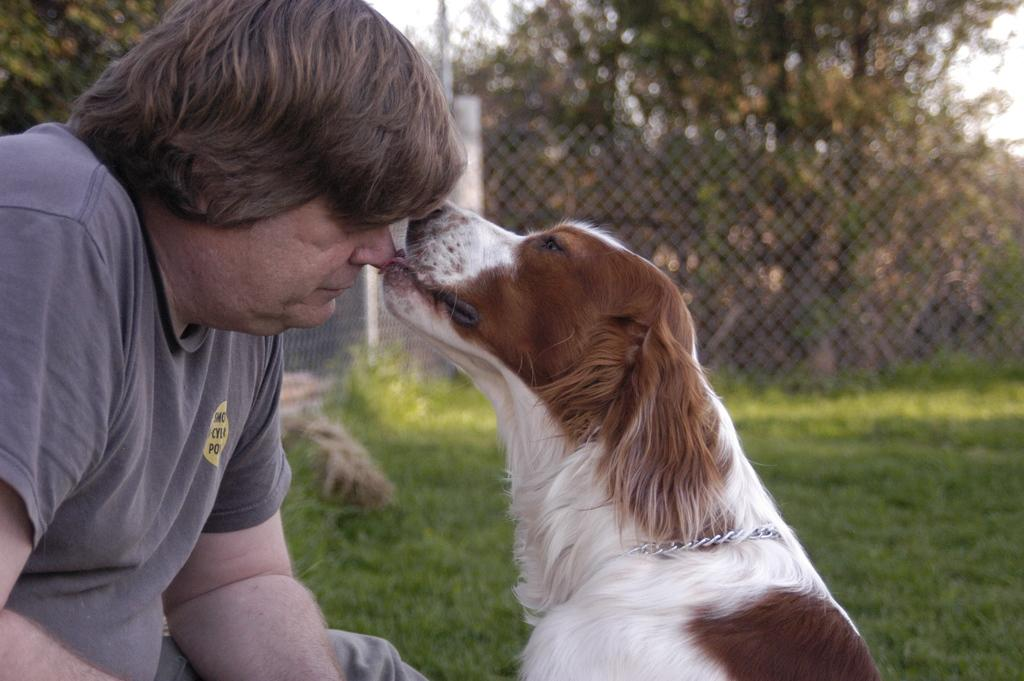Who or what is present in the image with the person? There is a dog in the image with the person. How is the dog connected to the person? The dog has a leash, which suggests that it is being walked by the person. What is the dog doing in the image? The dog is licking the person. What can be seen in the background of the image? There are trees and a lawn in the background of the image. What is the distribution of zinc in the image? There is no mention of zinc in the image, so it cannot be determined how it is distributed. 